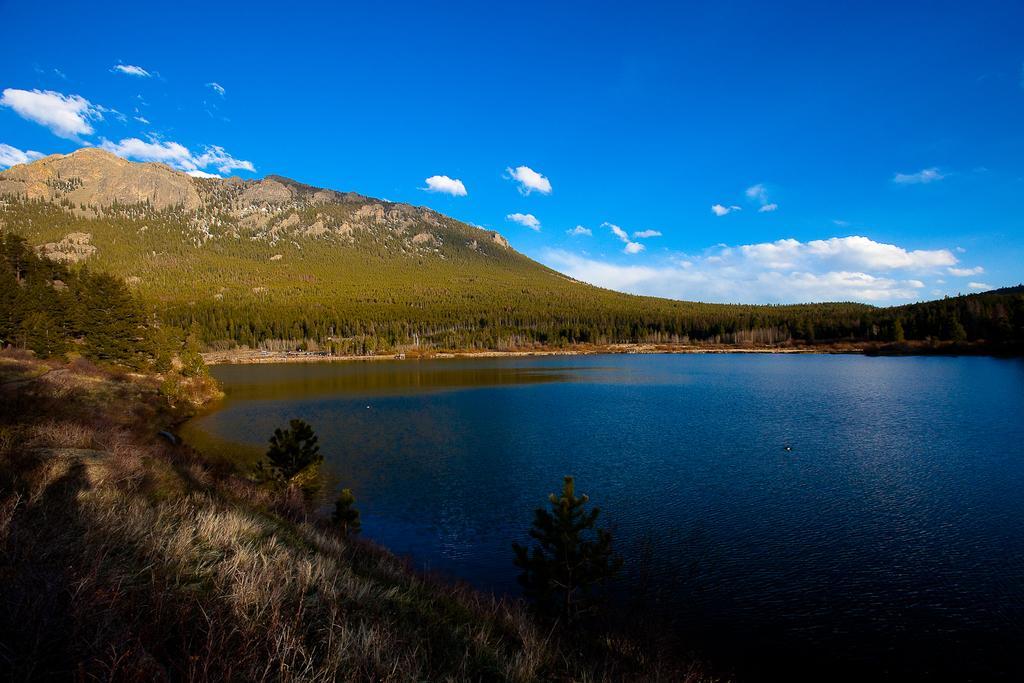Describe this image in one or two sentences. On the left side of the image there is grass on the ground. And also there are few trees. On the right side of the image there is water. In the background there is a hill with many trees. At the top of the image there is a sky with clouds.  